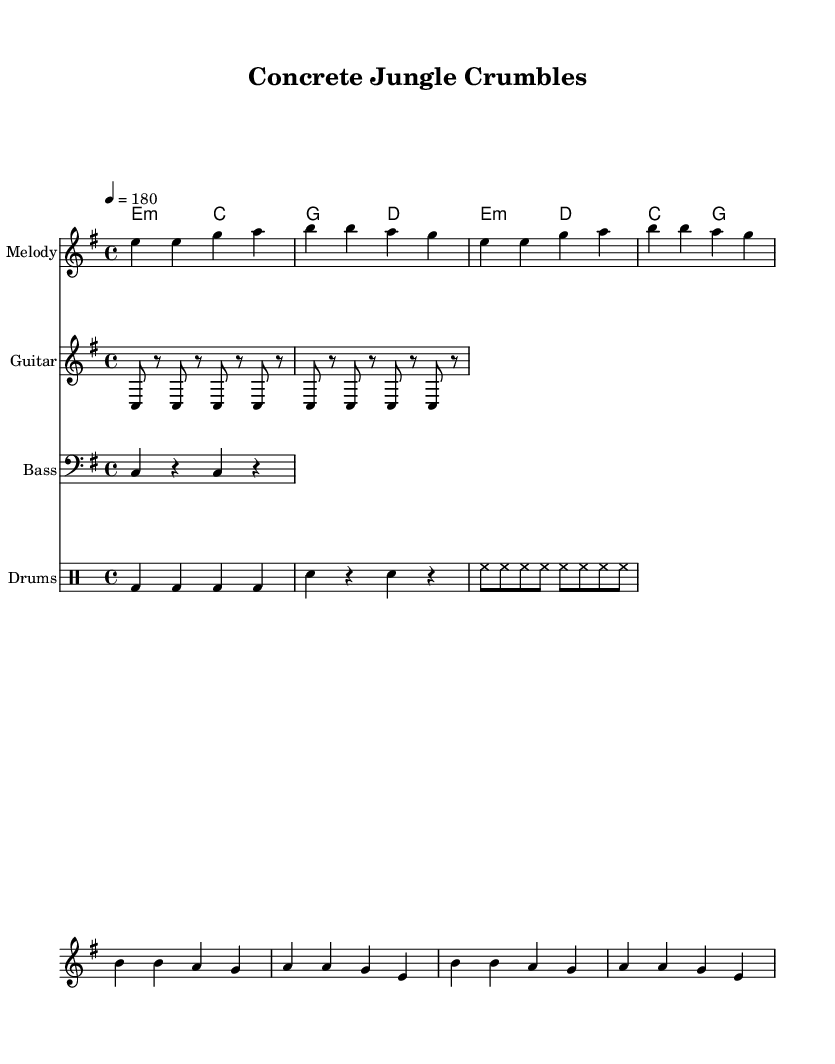What is the key signature of this music? The key signature is indicated at the beginning of the score, and it shows that there are no sharps or flats, meaning it is E minor.
Answer: E minor What is the time signature of the piece? The time signature is shown at the beginning of the score, represented as 4/4, which means there are four beats in a measure.
Answer: 4/4 What is the tempo marking of this piece? The tempo marking is provided in the score as "4 = 180," indicating that there are 180 beats per minute for a quarter note.
Answer: 180 How many measures are in the verse section? By scanning the verse part of the score, we count three lines of music; each line contains two measures, totaling six measures for the verse section.
Answer: 6 What is the lyric theme reflected in the chorus? The chorus lyrics express feelings about urban decay and lack of funding for repairs in the city, highlighting a sense of neglect and disrepair.
Answer: Urban decay What instruments are featured in this sheet music? The score clearly labels different sections for various instruments: Melody, Guitar, Bass, and Drums, indicating a diverse instrumentation typical of punk rock.
Answer: Melody, Guitar, Bass, Drums What chords are used in the chorus? The chords for the chorus can be found in the chord names section, which lists e minor, d major, c major, and g major, indicating the harmonic structure.
Answer: E minor, D major, C major, G major 